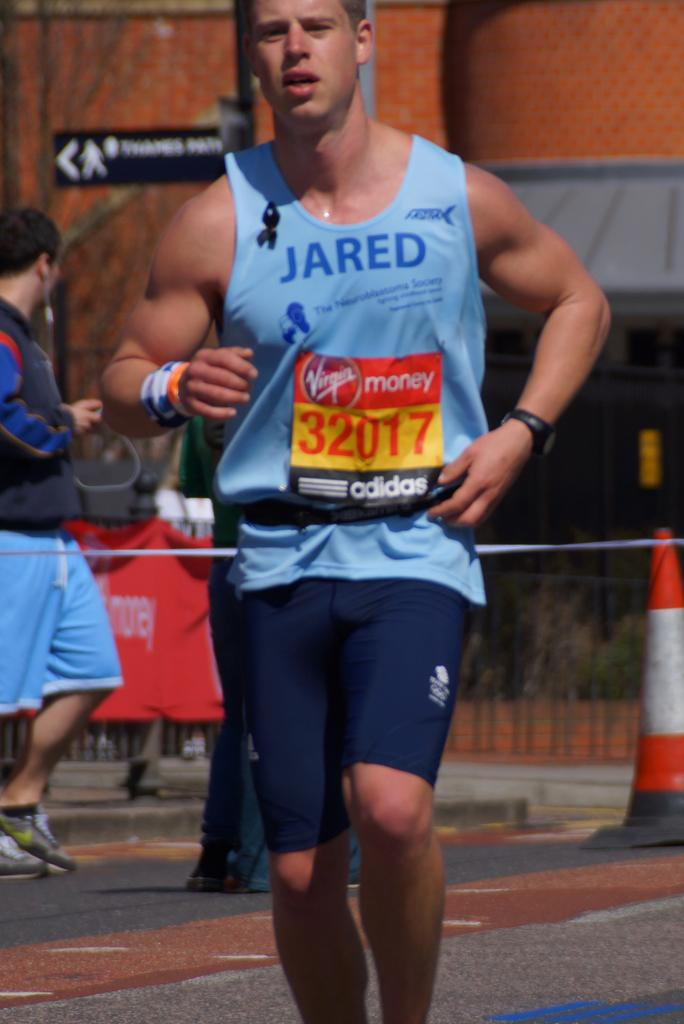<image>
Render a clear and concise summary of the photo. A man running in a race is wearing a shirt that says Jared. 